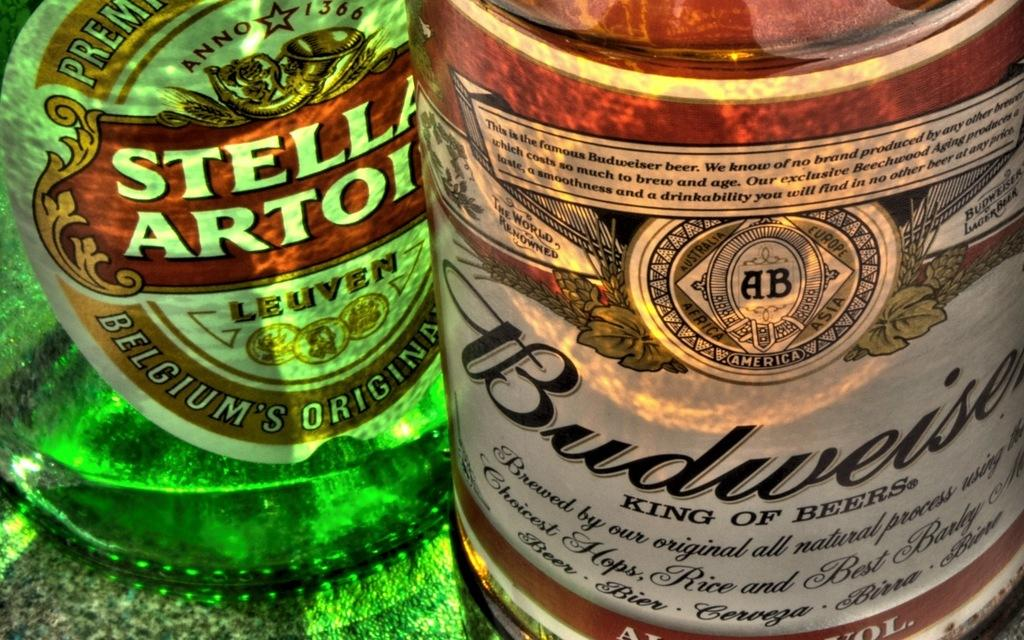<image>
Relay a brief, clear account of the picture shown. A bottle of Stella and Budweiser beer next to each other. 